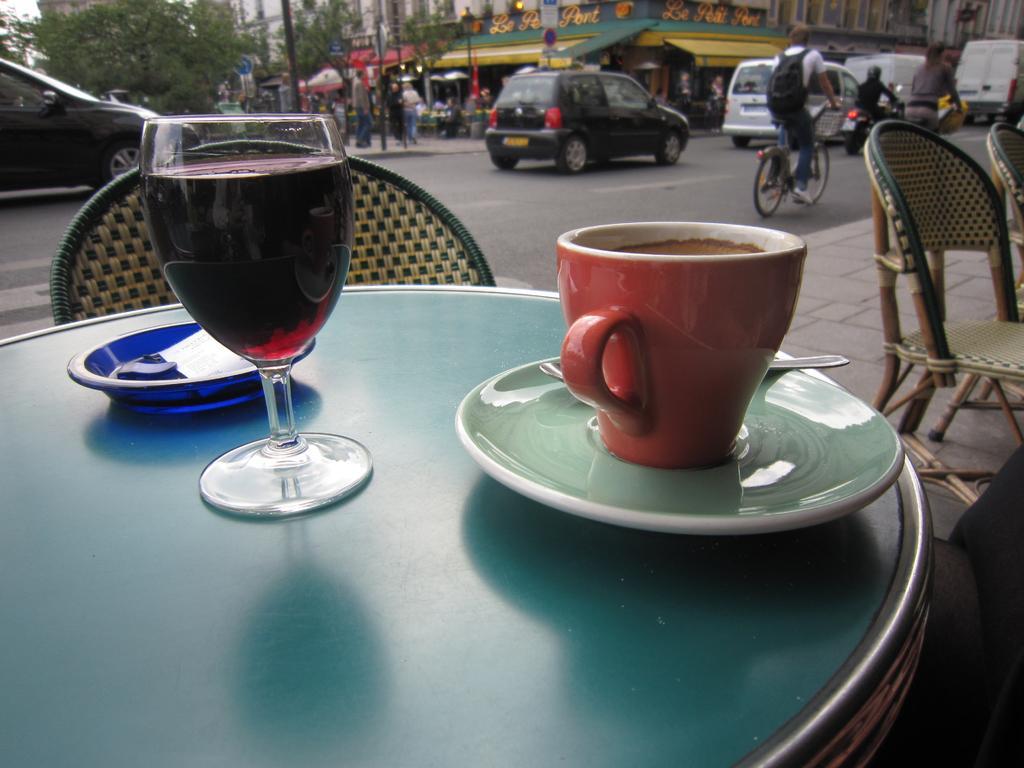Could you give a brief overview of what you see in this image? In this picture I can see a glass and I can see a tea cup and a spoon in the saucer and I can see another plate with a paper on the table and I can see few chairs and few cars and vehicles moving on the road and I can see trees and buildings and few people walking on the sidewalk. 